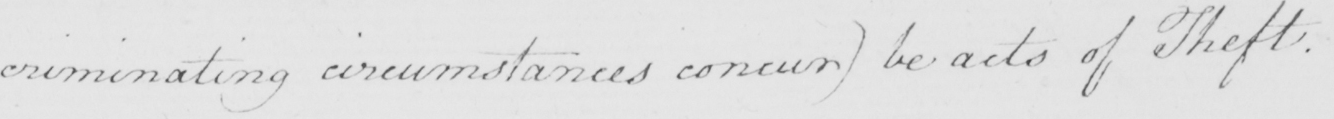What text is written in this handwritten line? criminating circumstances concur )  be acts of Theft . 